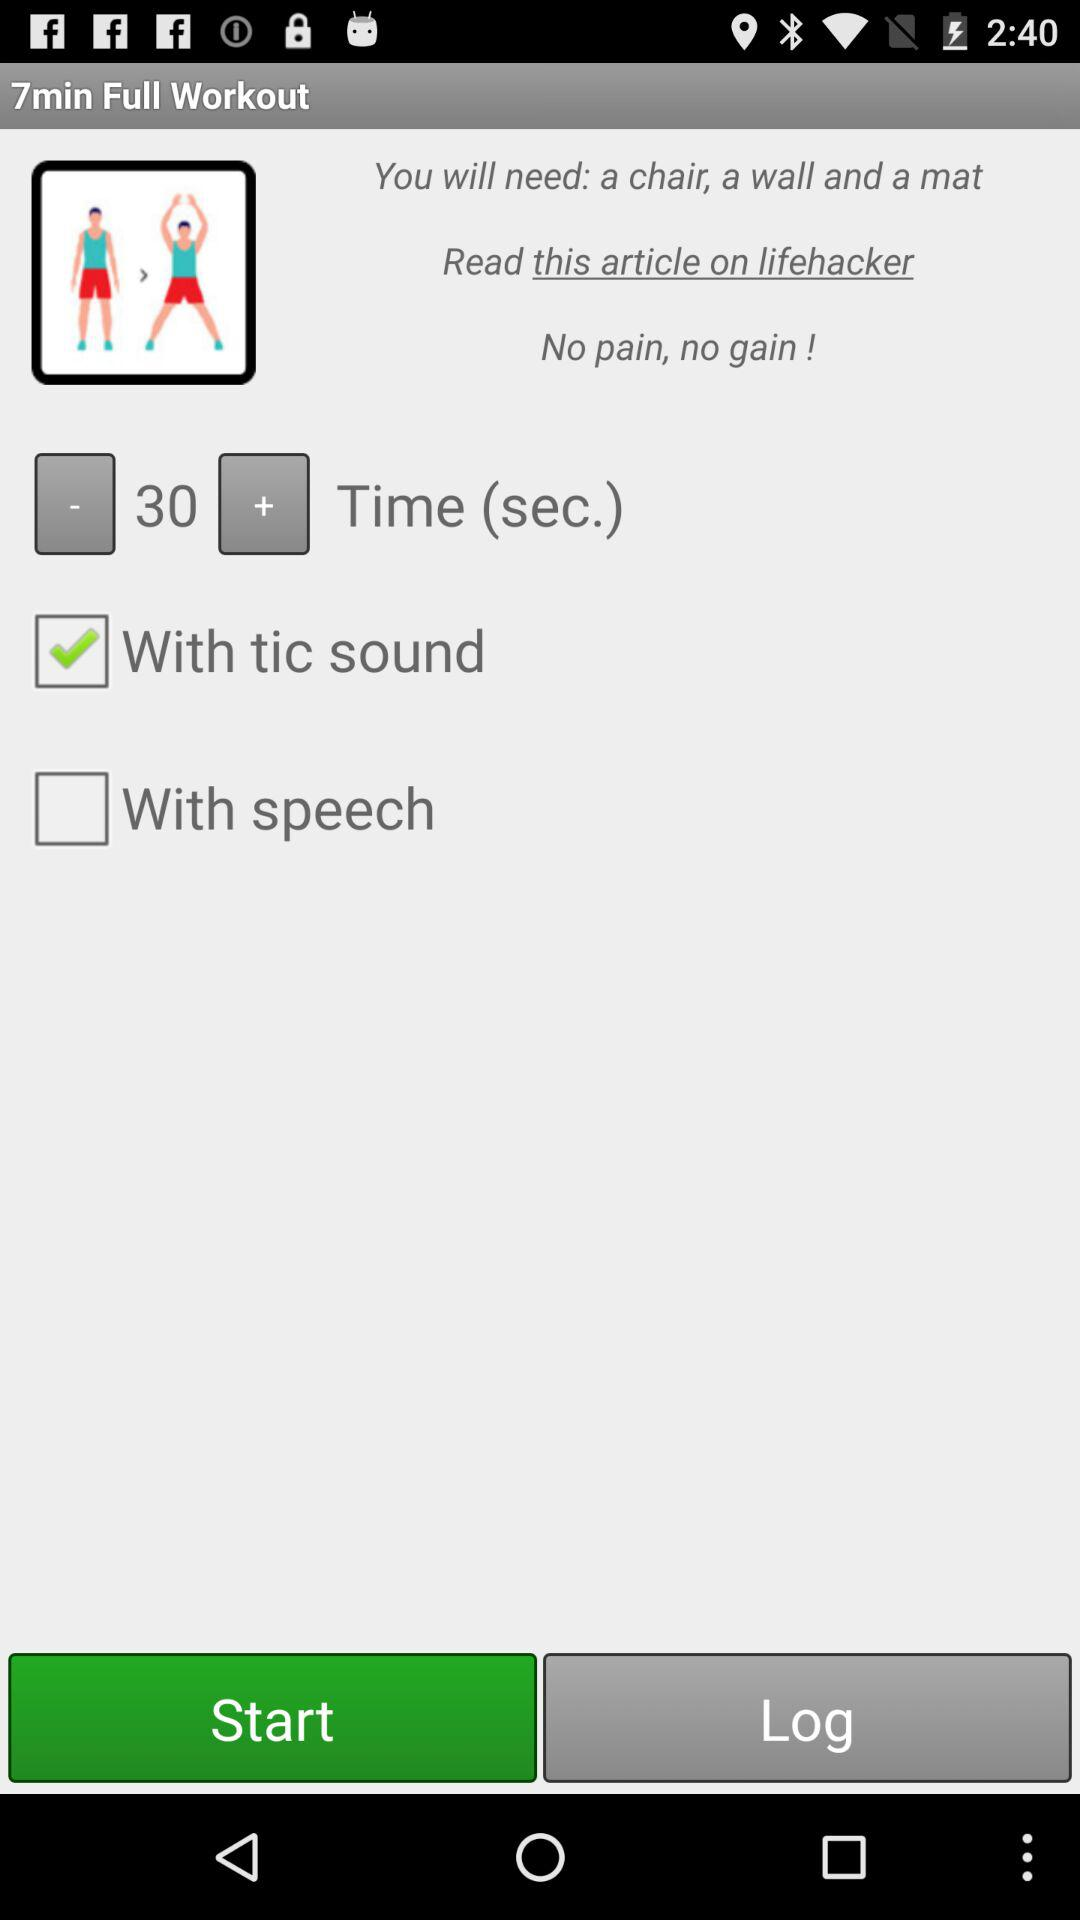What time duration is set on the timer? The time duration that is set on the timer is 30 seconds. 